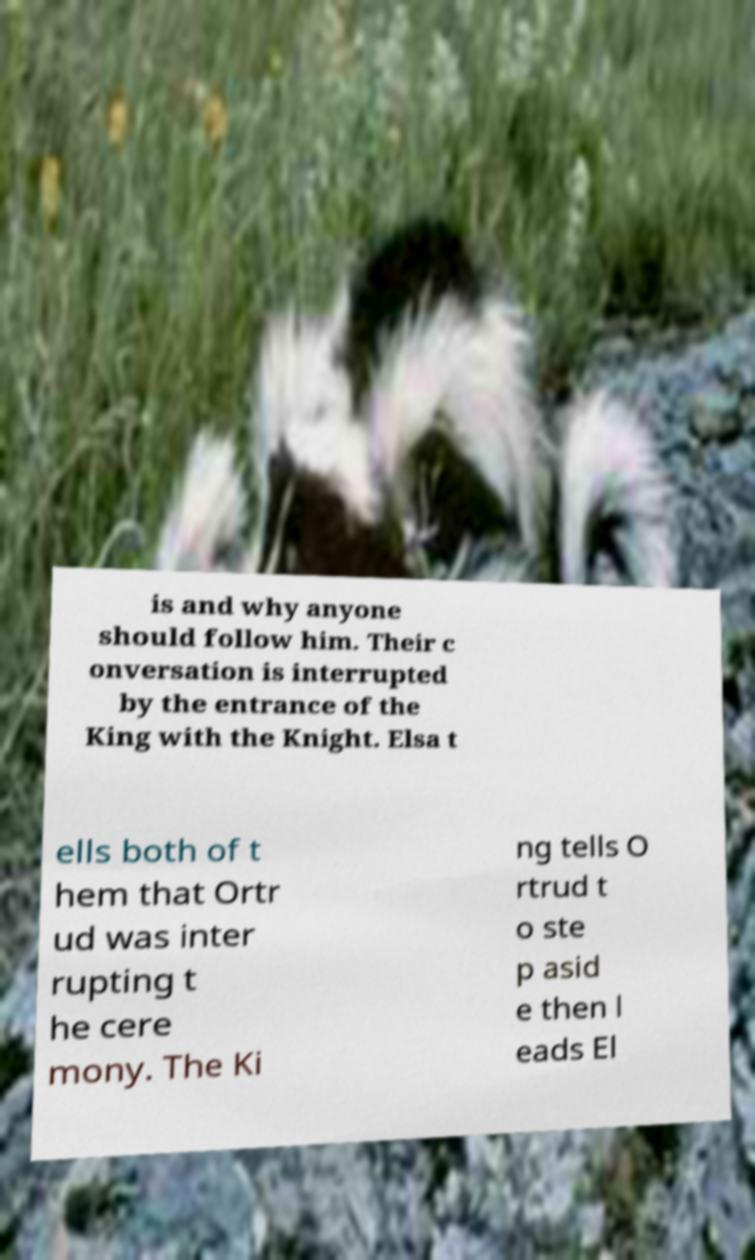Please read and relay the text visible in this image. What does it say? is and why anyone should follow him. Their c onversation is interrupted by the entrance of the King with the Knight. Elsa t ells both of t hem that Ortr ud was inter rupting t he cere mony. The Ki ng tells O rtrud t o ste p asid e then l eads El 